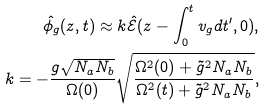<formula> <loc_0><loc_0><loc_500><loc_500>\hat { \phi _ { g } } ( z , t ) \approx k \hat { \mathcal { E } } ( z - \int _ { 0 } ^ { t } v _ { g } d t ^ { \prime } , 0 ) , \\ k = - \frac { g \sqrt { N _ { a } N _ { b } } } { \Omega ( 0 ) } \sqrt { \frac { \Omega ^ { 2 } ( 0 ) + \tilde { g } ^ { 2 } N _ { a } N _ { b } } { \Omega ^ { 2 } ( t ) + \tilde { g } ^ { 2 } N _ { a } N _ { b } } } ,</formula> 